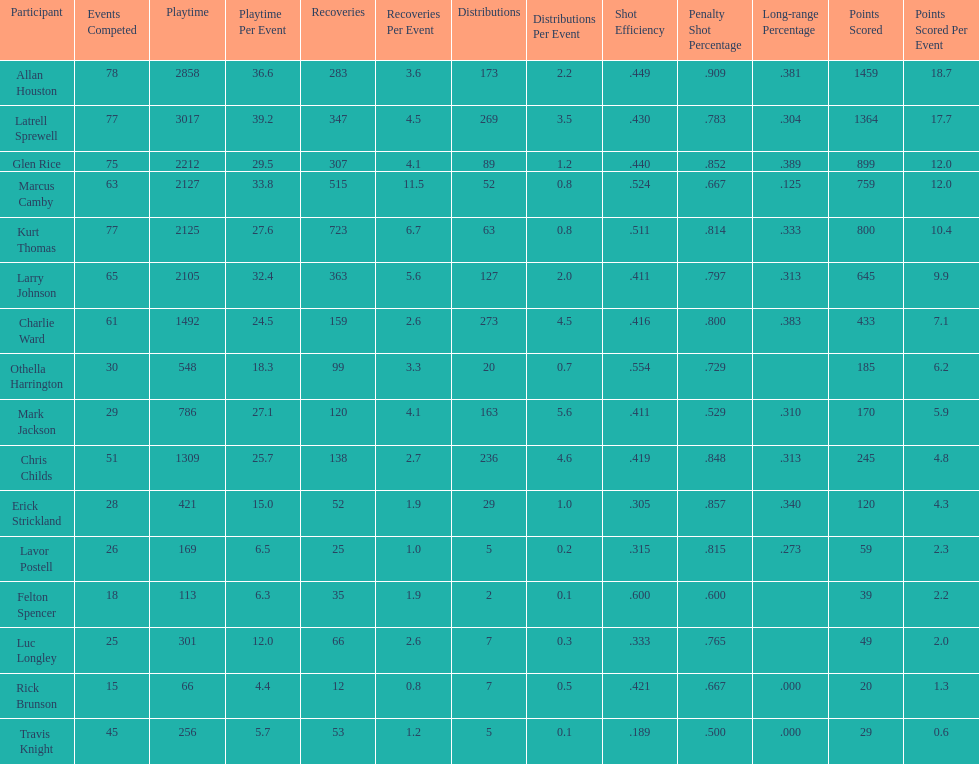Give the number of players covered by the table. 16. 